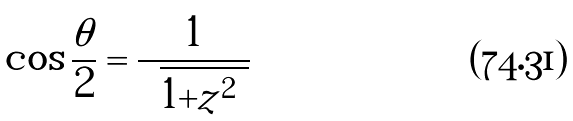Convert formula to latex. <formula><loc_0><loc_0><loc_500><loc_500>\cos \frac { \theta } { 2 } = \frac { 1 } { \sqrt { 1 + | z | ^ { 2 } } }</formula> 